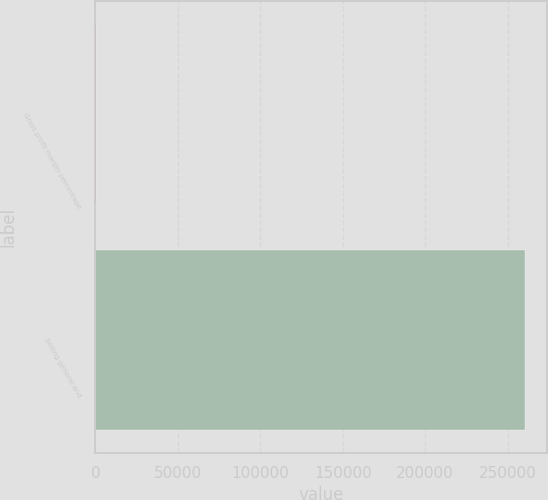Convert chart to OTSL. <chart><loc_0><loc_0><loc_500><loc_500><bar_chart><fcel>Gross profit margin percentage<fcel>Selling general and<nl><fcel>25.7<fcel>260795<nl></chart> 